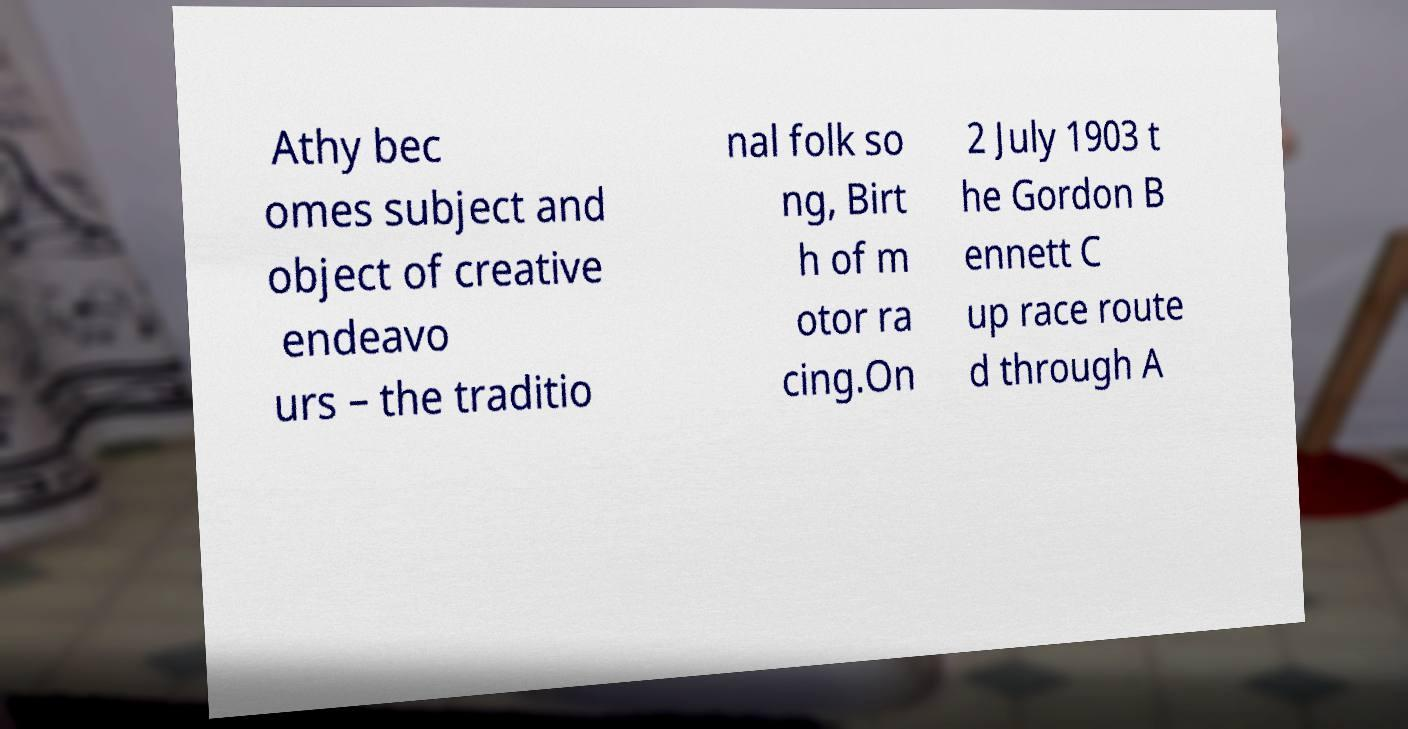Please identify and transcribe the text found in this image. Athy bec omes subject and object of creative endeavo urs – the traditio nal folk so ng, Birt h of m otor ra cing.On 2 July 1903 t he Gordon B ennett C up race route d through A 